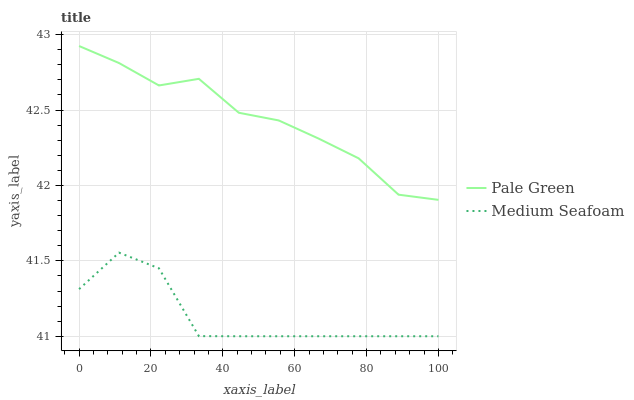Does Medium Seafoam have the maximum area under the curve?
Answer yes or no. No. Is Medium Seafoam the smoothest?
Answer yes or no. No. Does Medium Seafoam have the highest value?
Answer yes or no. No. Is Medium Seafoam less than Pale Green?
Answer yes or no. Yes. Is Pale Green greater than Medium Seafoam?
Answer yes or no. Yes. Does Medium Seafoam intersect Pale Green?
Answer yes or no. No. 